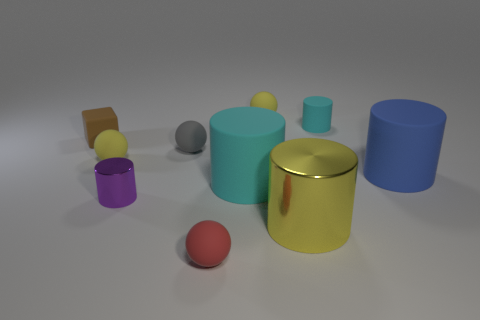Can you guess which one of these objects might weigh the most and why? The large blue cylinder on the right might weigh the most due to its size and volume. It appears to have a solid construction, which, if made of a dense material such as metal or ceramic, would contribute significantly to its weight. 